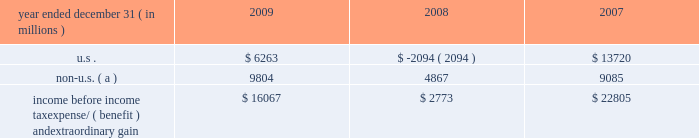Notes to consolidated financial statements jpmorgan chase & co./2009 annual report 236 the table presents the u.s .
And non-u.s .
Components of income before income tax expense/ ( benefit ) and extraordinary gain for the years ended december 31 , 2009 , 2008 and 2007 .
Year ended december 31 , ( in millions ) 2009 2008 2007 .
Non-u.s. ( a ) 9804 4867 9085 income before income tax expense/ ( benefit ) and extraordinary gain $ 16067 $ 2773 $ 22805 ( a ) for purposes of this table , non-u.s .
Income is defined as income generated from operations located outside the u.s .
Note 28 2013 restrictions on cash and inter- company funds transfers the business of jpmorgan chase bank , national association ( 201cjpmorgan chase bank , n.a . 201d ) is subject to examination and regulation by the office of the comptroller of the currency ( 201cocc 201d ) .
The bank is a member of the u.s .
Federal reserve sys- tem , and its deposits are insured by the fdic .
The board of governors of the federal reserve system ( the 201cfed- eral reserve 201d ) requires depository institutions to maintain cash reserves with a federal reserve bank .
The average amount of reserve balances deposited by the firm 2019s bank subsidiaries with various federal reserve banks was approximately $ 821 million and $ 1.6 billion in 2009 and 2008 , respectively .
Restrictions imposed by u.s .
Federal law prohibit jpmorgan chase and certain of its affiliates from borrowing from banking subsidiar- ies unless the loans are secured in specified amounts .
Such secured loans to the firm or to other affiliates are generally limited to 10% ( 10 % ) of the banking subsidiary 2019s total capital , as determined by the risk- based capital guidelines ; the aggregate amount of all such loans is limited to 20% ( 20 % ) of the banking subsidiary 2019s total capital .
The principal sources of jpmorgan chase 2019s income ( on a parent company 2013only basis ) are dividends and interest from jpmorgan chase bank , n.a. , and the other banking and nonbanking subsidi- aries of jpmorgan chase .
In addition to dividend restrictions set forth in statutes and regulations , the federal reserve , the occ and the fdic have authority under the financial institutions supervisory act to prohibit or to limit the payment of dividends by the banking organizations they supervise , including jpmorgan chase and its subsidiaries that are banks or bank holding companies , if , in the banking regulator 2019s opinion , payment of a dividend would consti- tute an unsafe or unsound practice in light of the financial condi- tion of the banking organization .
At january 1 , 2010 and 2009 , jpmorgan chase 2019s banking subsidi- aries could pay , in the aggregate , $ 3.6 billion and $ 17.0 billion , respectively , in dividends to their respective bank holding compa- nies without the prior approval of their relevant banking regulators .
The capacity to pay dividends in 2010 will be supplemented by the banking subsidiaries 2019 earnings during the year .
In compliance with rules and regulations established by u.s .
And non-u.s .
Regulators , as of december 31 , 2009 and 2008 , cash in the amount of $ 24.0 billion and $ 34.8 billion , respectively , and securities with a fair value of $ 10.2 billion and $ 23.4 billion , re- spectively , were segregated in special bank accounts for the benefit of securities and futures brokerage customers .
Note 29 2013 capital the federal reserve establishes capital requirements , including well-capitalized standards for the consolidated financial holding company .
The occ establishes similar capital requirements and standards for the firm 2019s national banks , including jpmorgan chase bank , n.a. , and chase bank usa , n.a .
There are two categories of risk-based capital : tier 1 capital and tier 2 capital .
Tier 1 capital includes common stockholders 2019 equity , qualifying preferred stock and minority interest less goodwill and other adjustments .
Tier 2 capital consists of preferred stock not qualifying as tier 1 , subordinated long-term debt and other instru- ments qualifying as tier 2 , and the aggregate allowance for credit losses up to a certain percentage of risk-weighted assets .
Total regulatory capital is subject to deductions for investments in certain subsidiaries .
Under the risk-based capital guidelines of the federal reserve , jpmorgan chase is required to maintain minimum ratios of tier 1 and total ( tier 1 plus tier 2 ) capital to risk-weighted assets , as well as minimum leverage ratios ( which are defined as tier 1 capital to average adjusted on 2013balance sheet assets ) .
Failure to meet these minimum requirements could cause the federal reserve to take action .
Banking subsidiaries also are subject to these capital requirements by their respective primary regulators .
As of december 31 , 2009 and 2008 , jpmorgan chase and all of its banking sub- sidiaries were well-capitalized and met all capital requirements to which each was subject. .
In 2009 what was the ratio of the cash to securities segregated special bank accounts for the benefit of securities and futures brokerage customers? 
Computations: (24.0 / 10.2)
Answer: 2.35294. 